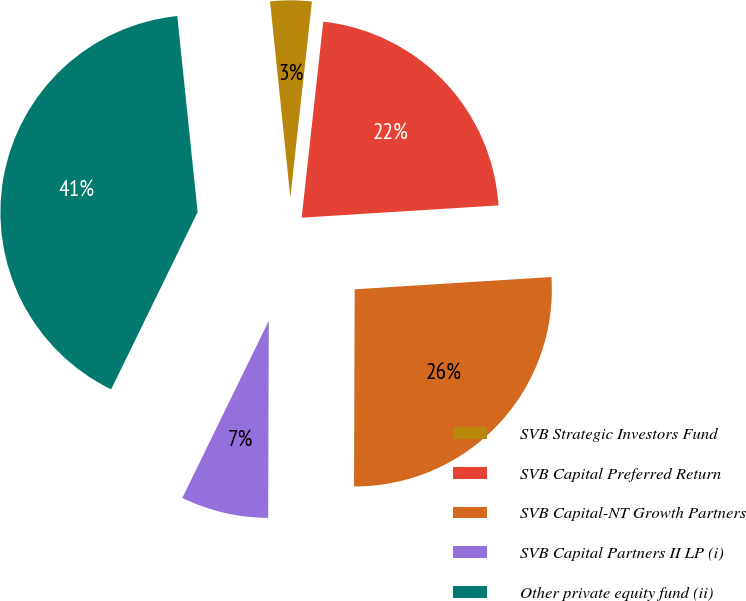Convert chart. <chart><loc_0><loc_0><loc_500><loc_500><pie_chart><fcel>SVB Strategic Investors Fund<fcel>SVB Capital Preferred Return<fcel>SVB Capital-NT Growth Partners<fcel>SVB Capital Partners II LP (i)<fcel>Other private equity fund (ii)<nl><fcel>3.39%<fcel>22.26%<fcel>26.04%<fcel>7.17%<fcel>41.13%<nl></chart> 